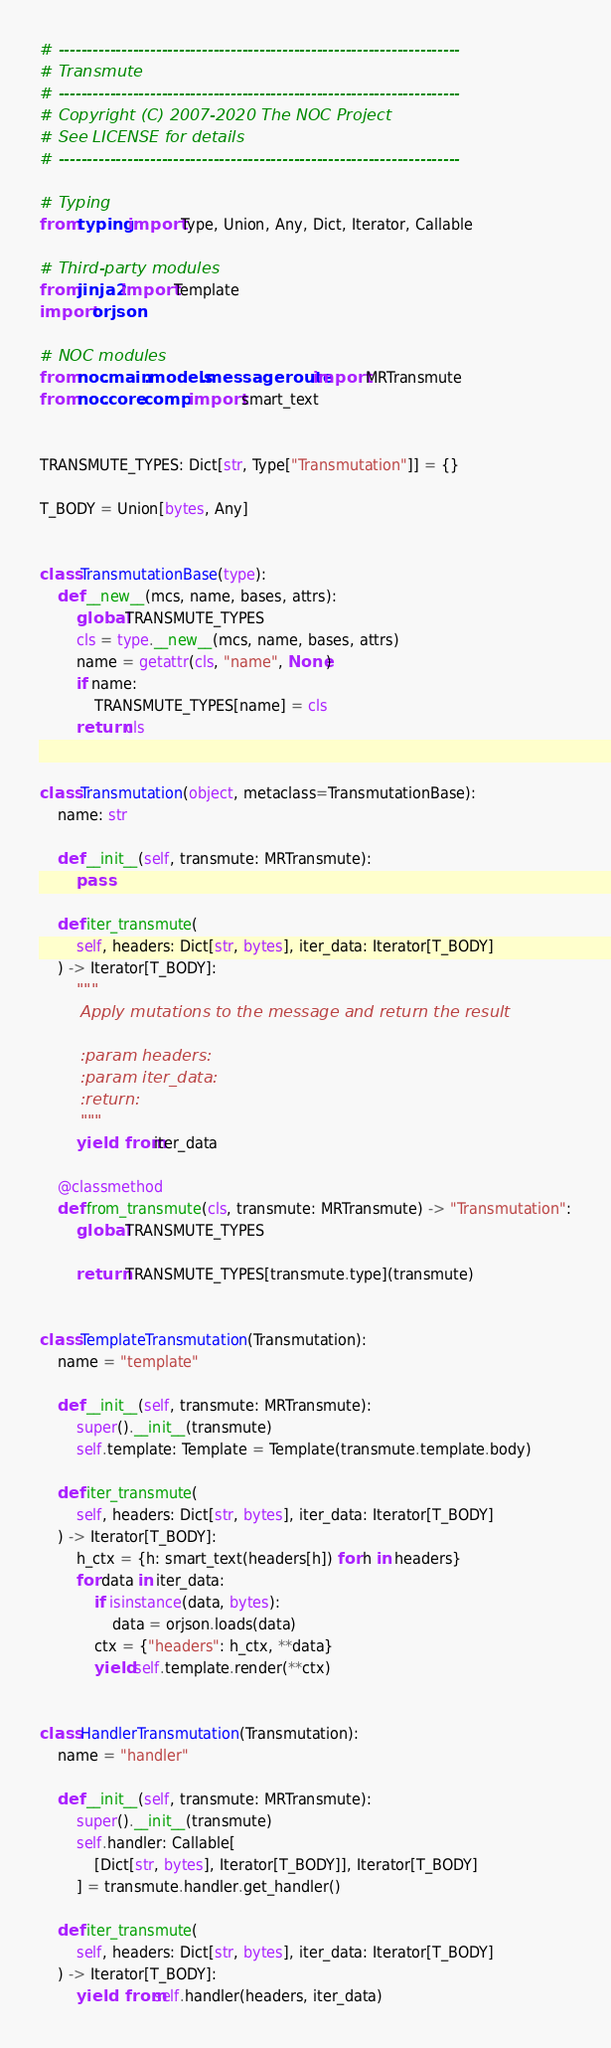<code> <loc_0><loc_0><loc_500><loc_500><_Python_># ----------------------------------------------------------------------
# Transmute
# ----------------------------------------------------------------------
# Copyright (C) 2007-2020 The NOC Project
# See LICENSE for details
# ----------------------------------------------------------------------

# Typing
from typing import Type, Union, Any, Dict, Iterator, Callable

# Third-party modules
from jinja2 import Template
import orjson

# NOC modules
from noc.main.models.messageroute import MRTransmute
from noc.core.comp import smart_text


TRANSMUTE_TYPES: Dict[str, Type["Transmutation"]] = {}

T_BODY = Union[bytes, Any]


class TransmutationBase(type):
    def __new__(mcs, name, bases, attrs):
        global TRANSMUTE_TYPES
        cls = type.__new__(mcs, name, bases, attrs)
        name = getattr(cls, "name", None)
        if name:
            TRANSMUTE_TYPES[name] = cls
        return cls


class Transmutation(object, metaclass=TransmutationBase):
    name: str

    def __init__(self, transmute: MRTransmute):
        pass

    def iter_transmute(
        self, headers: Dict[str, bytes], iter_data: Iterator[T_BODY]
    ) -> Iterator[T_BODY]:
        """
        Apply mutations to the message and return the result

        :param headers:
        :param iter_data:
        :return:
        """
        yield from iter_data

    @classmethod
    def from_transmute(cls, transmute: MRTransmute) -> "Transmutation":
        global TRANSMUTE_TYPES

        return TRANSMUTE_TYPES[transmute.type](transmute)


class TemplateTransmutation(Transmutation):
    name = "template"

    def __init__(self, transmute: MRTransmute):
        super().__init__(transmute)
        self.template: Template = Template(transmute.template.body)

    def iter_transmute(
        self, headers: Dict[str, bytes], iter_data: Iterator[T_BODY]
    ) -> Iterator[T_BODY]:
        h_ctx = {h: smart_text(headers[h]) for h in headers}
        for data in iter_data:
            if isinstance(data, bytes):
                data = orjson.loads(data)
            ctx = {"headers": h_ctx, **data}
            yield self.template.render(**ctx)


class HandlerTransmutation(Transmutation):
    name = "handler"

    def __init__(self, transmute: MRTransmute):
        super().__init__(transmute)
        self.handler: Callable[
            [Dict[str, bytes], Iterator[T_BODY]], Iterator[T_BODY]
        ] = transmute.handler.get_handler()

    def iter_transmute(
        self, headers: Dict[str, bytes], iter_data: Iterator[T_BODY]
    ) -> Iterator[T_BODY]:
        yield from self.handler(headers, iter_data)
</code> 